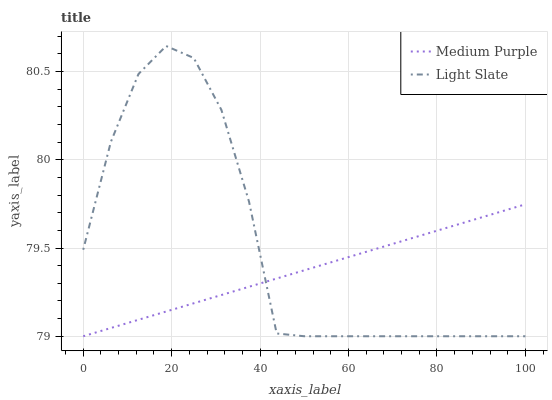Does Medium Purple have the minimum area under the curve?
Answer yes or no. Yes. Does Light Slate have the maximum area under the curve?
Answer yes or no. Yes. Does Light Slate have the minimum area under the curve?
Answer yes or no. No. Is Medium Purple the smoothest?
Answer yes or no. Yes. Is Light Slate the roughest?
Answer yes or no. Yes. Is Light Slate the smoothest?
Answer yes or no. No. Does Light Slate have the highest value?
Answer yes or no. Yes. Does Medium Purple intersect Light Slate?
Answer yes or no. Yes. Is Medium Purple less than Light Slate?
Answer yes or no. No. Is Medium Purple greater than Light Slate?
Answer yes or no. No. 